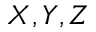<formula> <loc_0><loc_0><loc_500><loc_500>X , Y , Z</formula> 